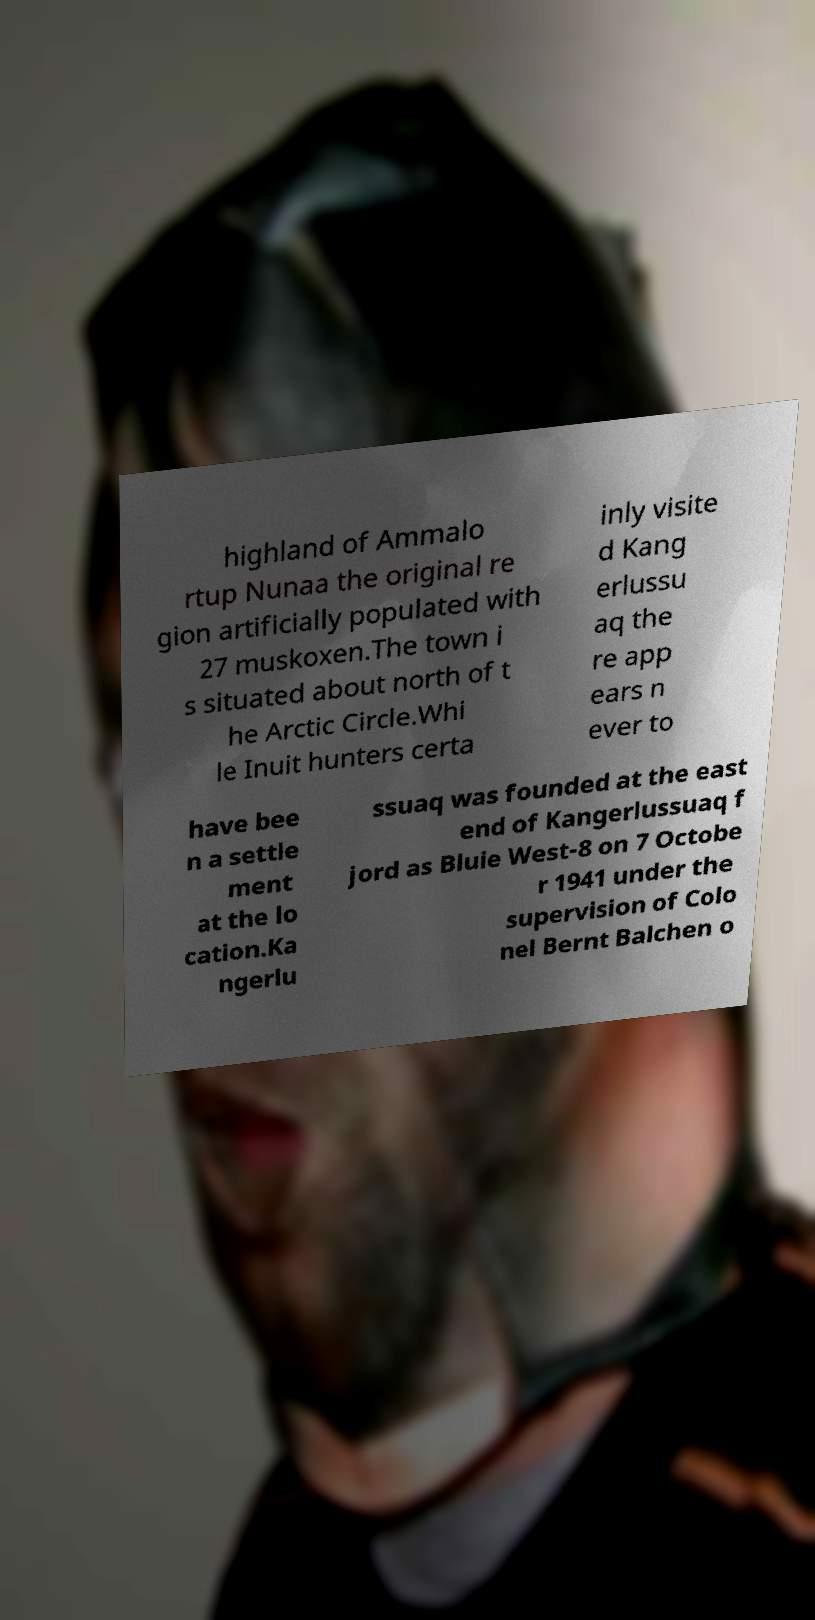Can you accurately transcribe the text from the provided image for me? highland of Ammalo rtup Nunaa the original re gion artificially populated with 27 muskoxen.The town i s situated about north of t he Arctic Circle.Whi le Inuit hunters certa inly visite d Kang erlussu aq the re app ears n ever to have bee n a settle ment at the lo cation.Ka ngerlu ssuaq was founded at the east end of Kangerlussuaq f jord as Bluie West-8 on 7 Octobe r 1941 under the supervision of Colo nel Bernt Balchen o 